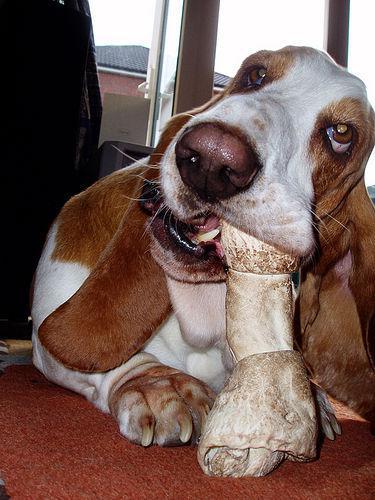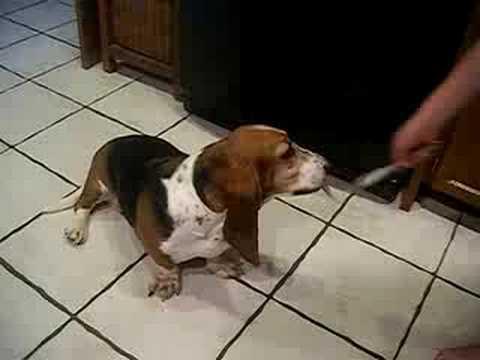The first image is the image on the left, the second image is the image on the right. Analyze the images presented: Is the assertion "There are no more than two dogs." valid? Answer yes or no. Yes. 